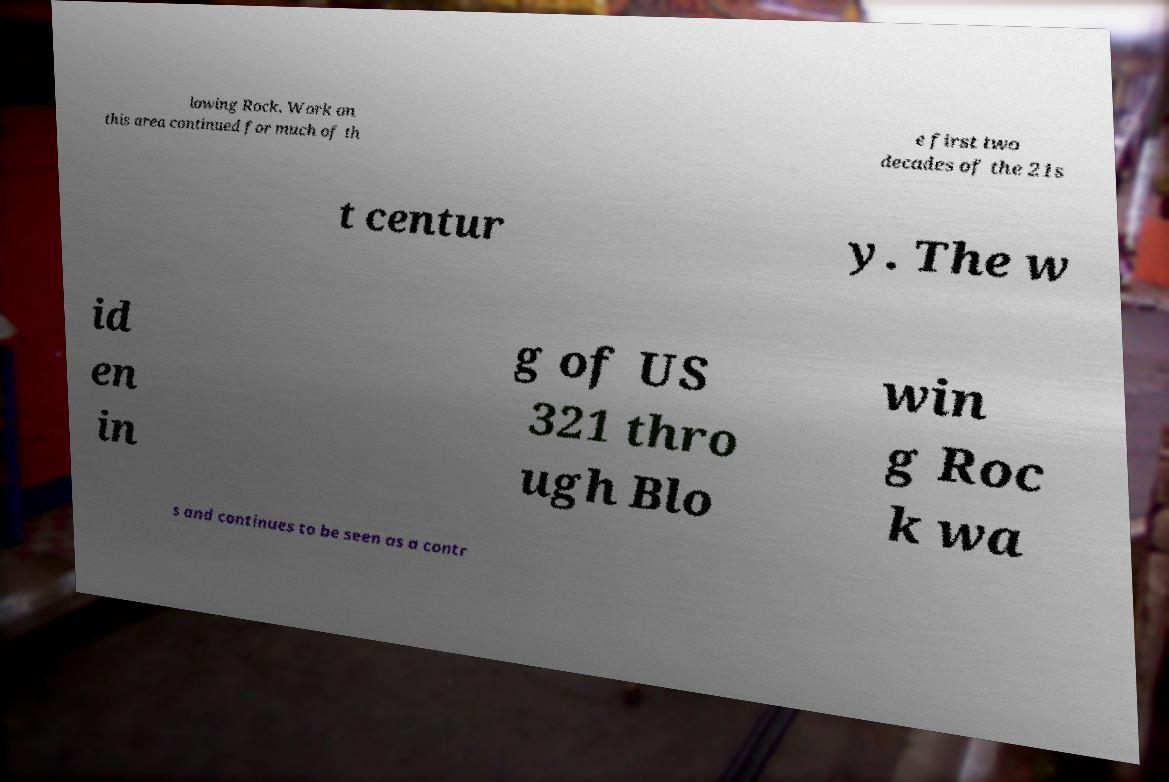Can you read and provide the text displayed in the image?This photo seems to have some interesting text. Can you extract and type it out for me? lowing Rock. Work on this area continued for much of th e first two decades of the 21s t centur y. The w id en in g of US 321 thro ugh Blo win g Roc k wa s and continues to be seen as a contr 